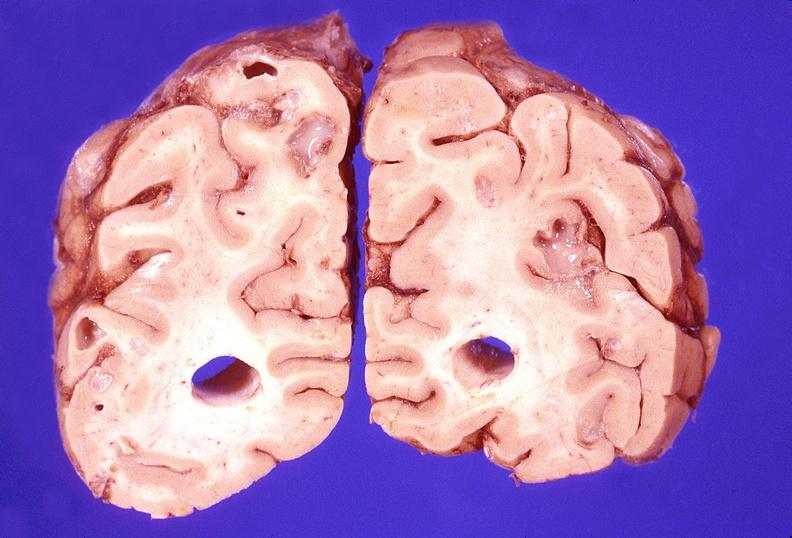what does this image show?
Answer the question using a single word or phrase. Brain abscess 